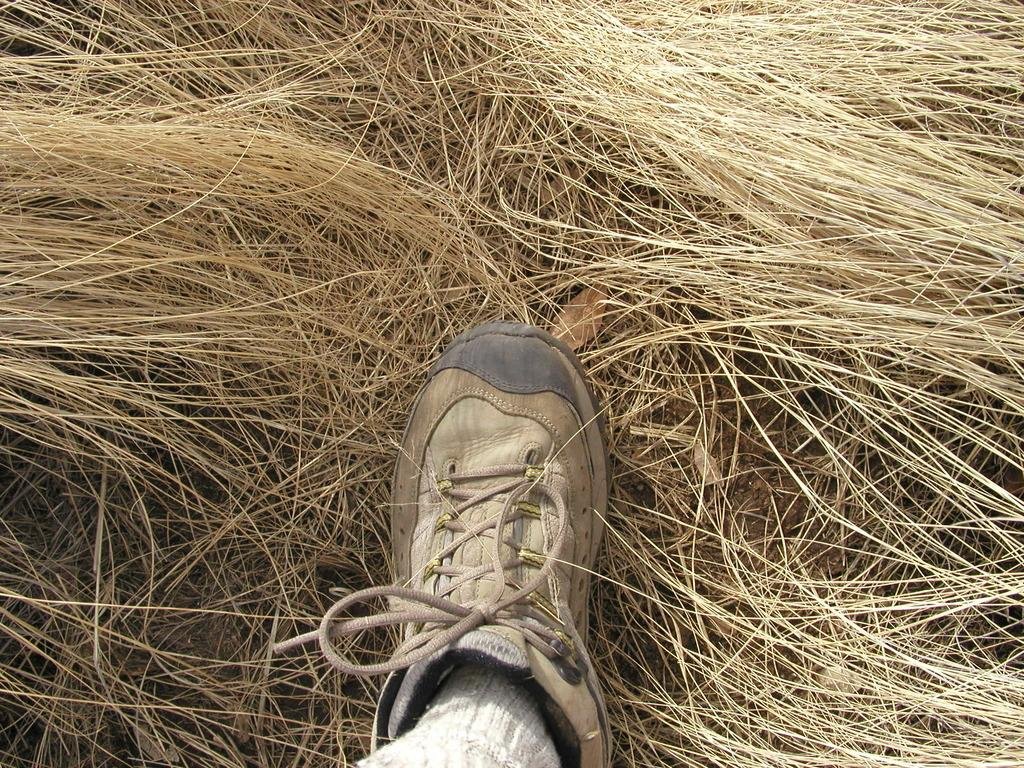What part of a person's body can be seen in the image? There is a person's leg visible in the image. What type of environment is depicted in the background of the image? There is grass in the background of the image. What is the condition of the person's leg in the image? The condition of the person's leg cannot be determined from the image alone, as it only shows a portion of the leg. 